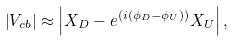<formula> <loc_0><loc_0><loc_500><loc_500>\left | { V _ { c b } } \right | \approx \left | { X _ { D } } - e ^ { ( i ( { \phi _ { D } } - { \phi _ { U } } ) ) } { X _ { U } } \right | ,</formula> 